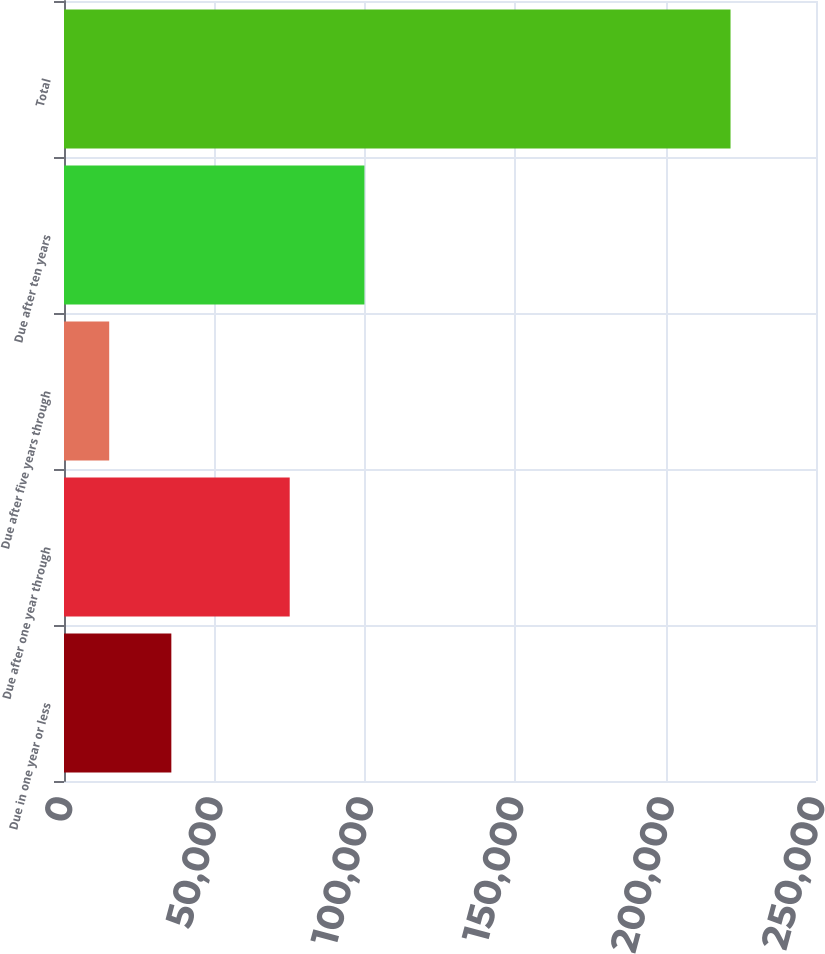Convert chart. <chart><loc_0><loc_0><loc_500><loc_500><bar_chart><fcel>Due in one year or less<fcel>Due after one year through<fcel>Due after five years through<fcel>Due after ten years<fcel>Total<nl><fcel>35685.7<fcel>75038<fcel>15030<fcel>99875<fcel>221587<nl></chart> 